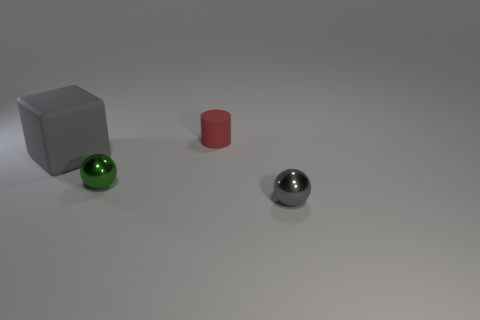Add 2 green cubes. How many objects exist? 6 Subtract all cylinders. How many objects are left? 3 Add 4 tiny matte cylinders. How many tiny matte cylinders exist? 5 Subtract 0 brown cylinders. How many objects are left? 4 Subtract all green things. Subtract all small shiny things. How many objects are left? 1 Add 3 red matte things. How many red matte things are left? 4 